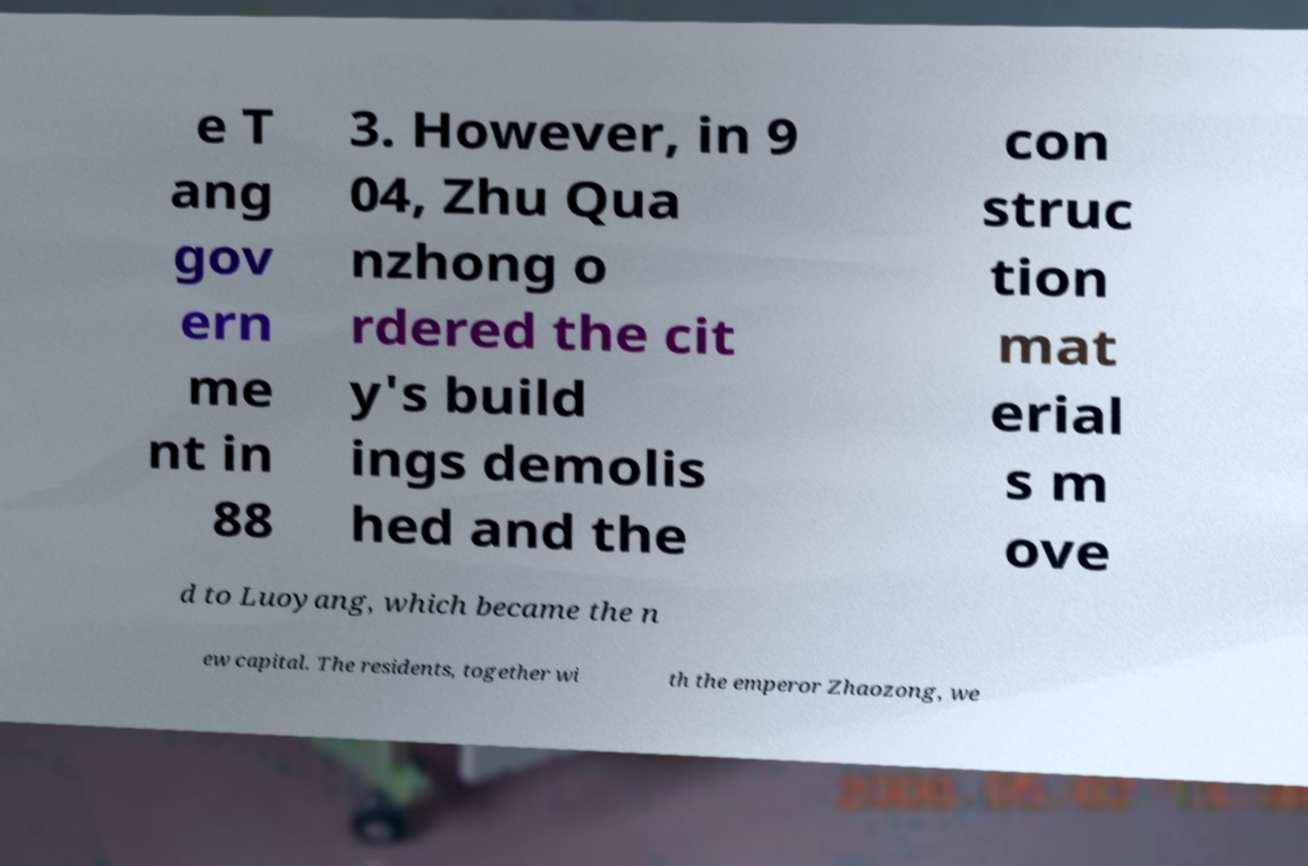Could you extract and type out the text from this image? e T ang gov ern me nt in 88 3. However, in 9 04, Zhu Qua nzhong o rdered the cit y's build ings demolis hed and the con struc tion mat erial s m ove d to Luoyang, which became the n ew capital. The residents, together wi th the emperor Zhaozong, we 